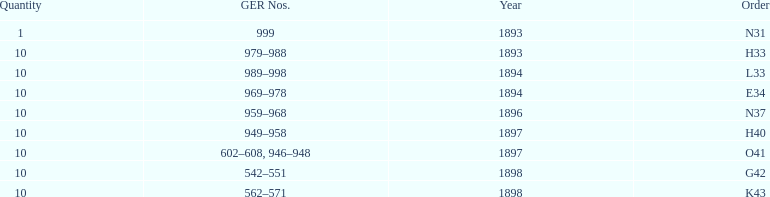Which year between 1893 and 1898 was there not an order? 1895. Would you be able to parse every entry in this table? {'header': ['Quantity', 'GER Nos.', 'Year', 'Order'], 'rows': [['1', '999', '1893', 'N31'], ['10', '979–988', '1893', 'H33'], ['10', '989–998', '1894', 'L33'], ['10', '969–978', '1894', 'E34'], ['10', '959–968', '1896', 'N37'], ['10', '949–958', '1897', 'H40'], ['10', '602–608, 946–948', '1897', 'O41'], ['10', '542–551', '1898', 'G42'], ['10', '562–571', '1898', 'K43']]} 